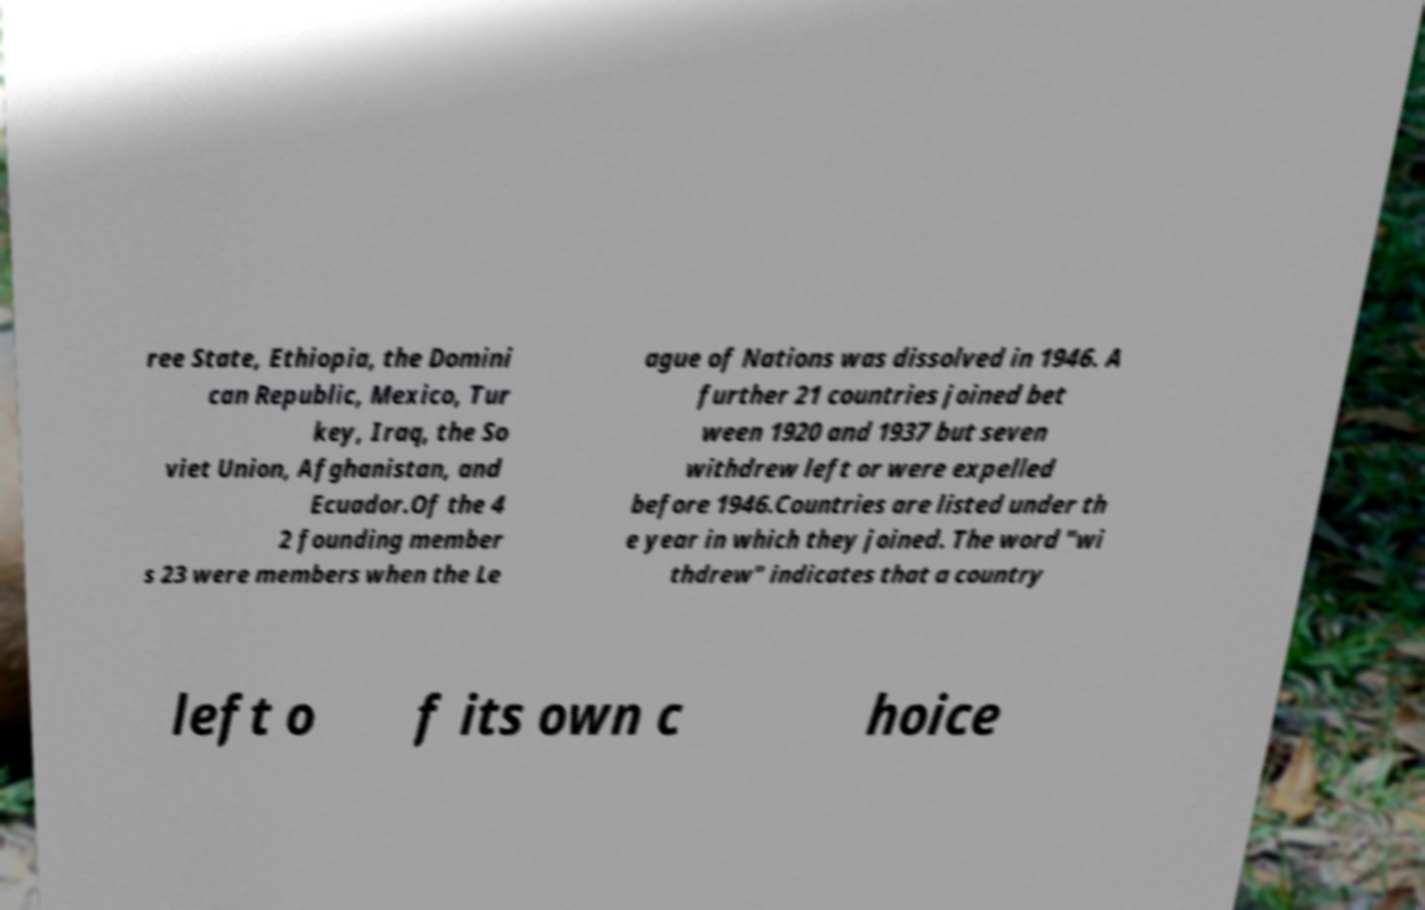For documentation purposes, I need the text within this image transcribed. Could you provide that? ree State, Ethiopia, the Domini can Republic, Mexico, Tur key, Iraq, the So viet Union, Afghanistan, and Ecuador.Of the 4 2 founding member s 23 were members when the Le ague of Nations was dissolved in 1946. A further 21 countries joined bet ween 1920 and 1937 but seven withdrew left or were expelled before 1946.Countries are listed under th e year in which they joined. The word "wi thdrew" indicates that a country left o f its own c hoice 